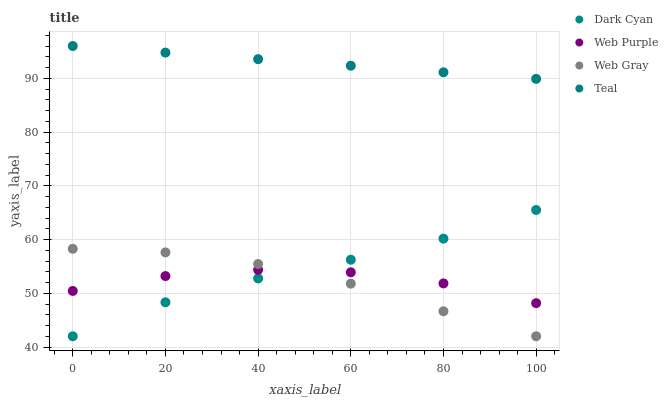Does Web Gray have the minimum area under the curve?
Answer yes or no. Yes. Does Teal have the maximum area under the curve?
Answer yes or no. Yes. Does Web Purple have the minimum area under the curve?
Answer yes or no. No. Does Web Purple have the maximum area under the curve?
Answer yes or no. No. Is Teal the smoothest?
Answer yes or no. Yes. Is Web Purple the roughest?
Answer yes or no. Yes. Is Web Gray the smoothest?
Answer yes or no. No. Is Web Gray the roughest?
Answer yes or no. No. Does Dark Cyan have the lowest value?
Answer yes or no. Yes. Does Web Purple have the lowest value?
Answer yes or no. No. Does Teal have the highest value?
Answer yes or no. Yes. Does Web Gray have the highest value?
Answer yes or no. No. Is Web Gray less than Teal?
Answer yes or no. Yes. Is Teal greater than Web Purple?
Answer yes or no. Yes. Does Web Purple intersect Web Gray?
Answer yes or no. Yes. Is Web Purple less than Web Gray?
Answer yes or no. No. Is Web Purple greater than Web Gray?
Answer yes or no. No. Does Web Gray intersect Teal?
Answer yes or no. No. 